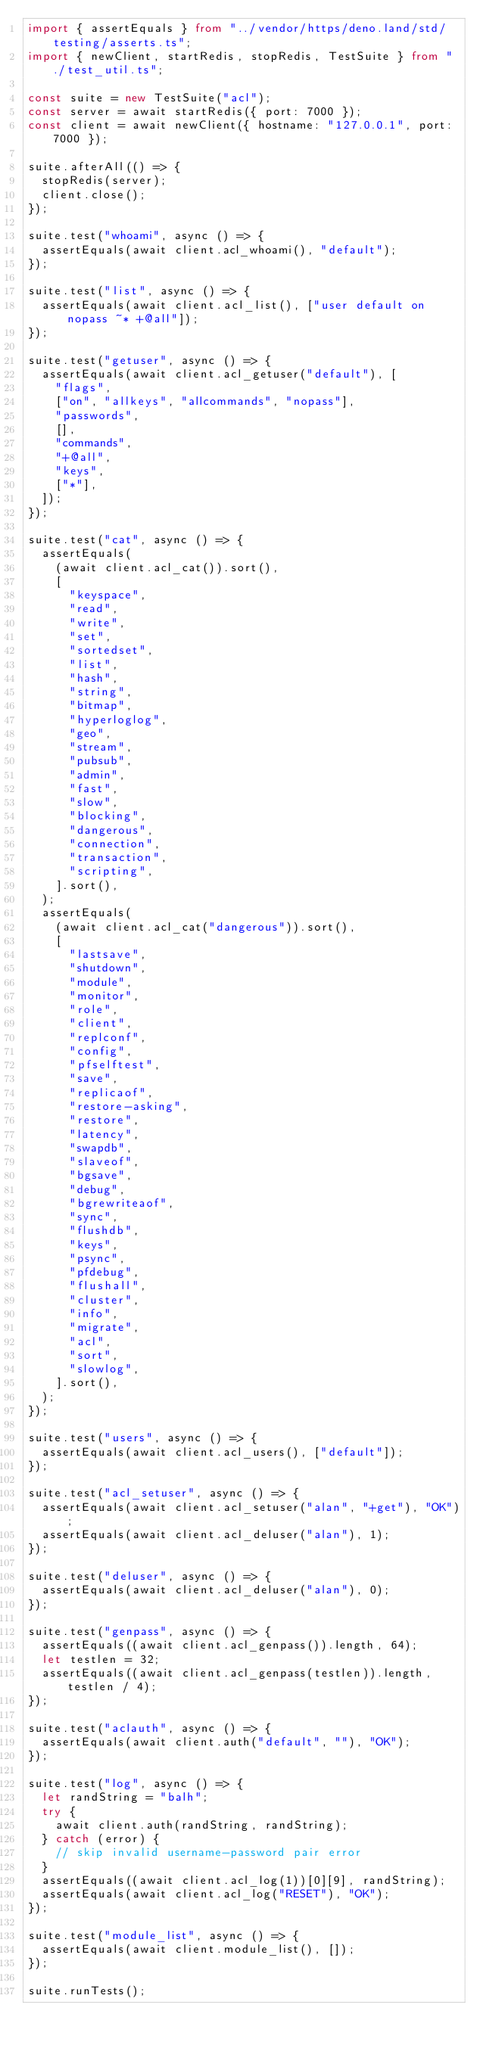<code> <loc_0><loc_0><loc_500><loc_500><_TypeScript_>import { assertEquals } from "../vendor/https/deno.land/std/testing/asserts.ts";
import { newClient, startRedis, stopRedis, TestSuite } from "./test_util.ts";

const suite = new TestSuite("acl");
const server = await startRedis({ port: 7000 });
const client = await newClient({ hostname: "127.0.0.1", port: 7000 });

suite.afterAll(() => {
  stopRedis(server);
  client.close();
});

suite.test("whoami", async () => {
  assertEquals(await client.acl_whoami(), "default");
});

suite.test("list", async () => {
  assertEquals(await client.acl_list(), ["user default on nopass ~* +@all"]);
});

suite.test("getuser", async () => {
  assertEquals(await client.acl_getuser("default"), [
    "flags",
    ["on", "allkeys", "allcommands", "nopass"],
    "passwords",
    [],
    "commands",
    "+@all",
    "keys",
    ["*"],
  ]);
});

suite.test("cat", async () => {
  assertEquals(
    (await client.acl_cat()).sort(),
    [
      "keyspace",
      "read",
      "write",
      "set",
      "sortedset",
      "list",
      "hash",
      "string",
      "bitmap",
      "hyperloglog",
      "geo",
      "stream",
      "pubsub",
      "admin",
      "fast",
      "slow",
      "blocking",
      "dangerous",
      "connection",
      "transaction",
      "scripting",
    ].sort(),
  );
  assertEquals(
    (await client.acl_cat("dangerous")).sort(),
    [
      "lastsave",
      "shutdown",
      "module",
      "monitor",
      "role",
      "client",
      "replconf",
      "config",
      "pfselftest",
      "save",
      "replicaof",
      "restore-asking",
      "restore",
      "latency",
      "swapdb",
      "slaveof",
      "bgsave",
      "debug",
      "bgrewriteaof",
      "sync",
      "flushdb",
      "keys",
      "psync",
      "pfdebug",
      "flushall",
      "cluster",
      "info",
      "migrate",
      "acl",
      "sort",
      "slowlog",
    ].sort(),
  );
});

suite.test("users", async () => {
  assertEquals(await client.acl_users(), ["default"]);
});

suite.test("acl_setuser", async () => {
  assertEquals(await client.acl_setuser("alan", "+get"), "OK");
  assertEquals(await client.acl_deluser("alan"), 1);
});

suite.test("deluser", async () => {
  assertEquals(await client.acl_deluser("alan"), 0);
});

suite.test("genpass", async () => {
  assertEquals((await client.acl_genpass()).length, 64);
  let testlen = 32;
  assertEquals((await client.acl_genpass(testlen)).length, testlen / 4);
});

suite.test("aclauth", async () => {
  assertEquals(await client.auth("default", ""), "OK");
});

suite.test("log", async () => {
  let randString = "balh";
  try {
    await client.auth(randString, randString);
  } catch (error) {
    // skip invalid username-password pair error
  }
  assertEquals((await client.acl_log(1))[0][9], randString);
  assertEquals(await client.acl_log("RESET"), "OK");
});

suite.test("module_list", async () => {
  assertEquals(await client.module_list(), []);
});

suite.runTests();
</code> 